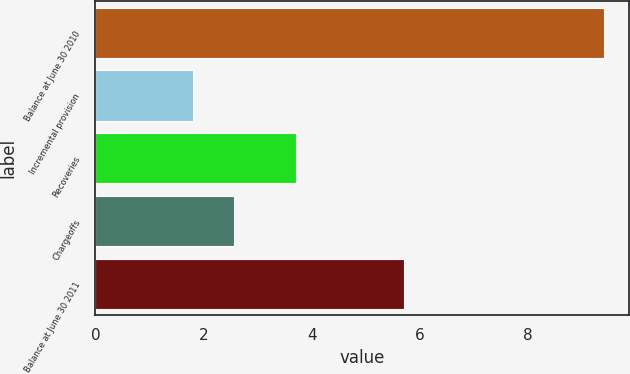Convert chart to OTSL. <chart><loc_0><loc_0><loc_500><loc_500><bar_chart><fcel>Balance at June 30 2010<fcel>Incremental provision<fcel>Recoveries<fcel>Chargeoffs<fcel>Balance at June 30 2011<nl><fcel>9.4<fcel>1.8<fcel>3.7<fcel>2.56<fcel>5.7<nl></chart> 